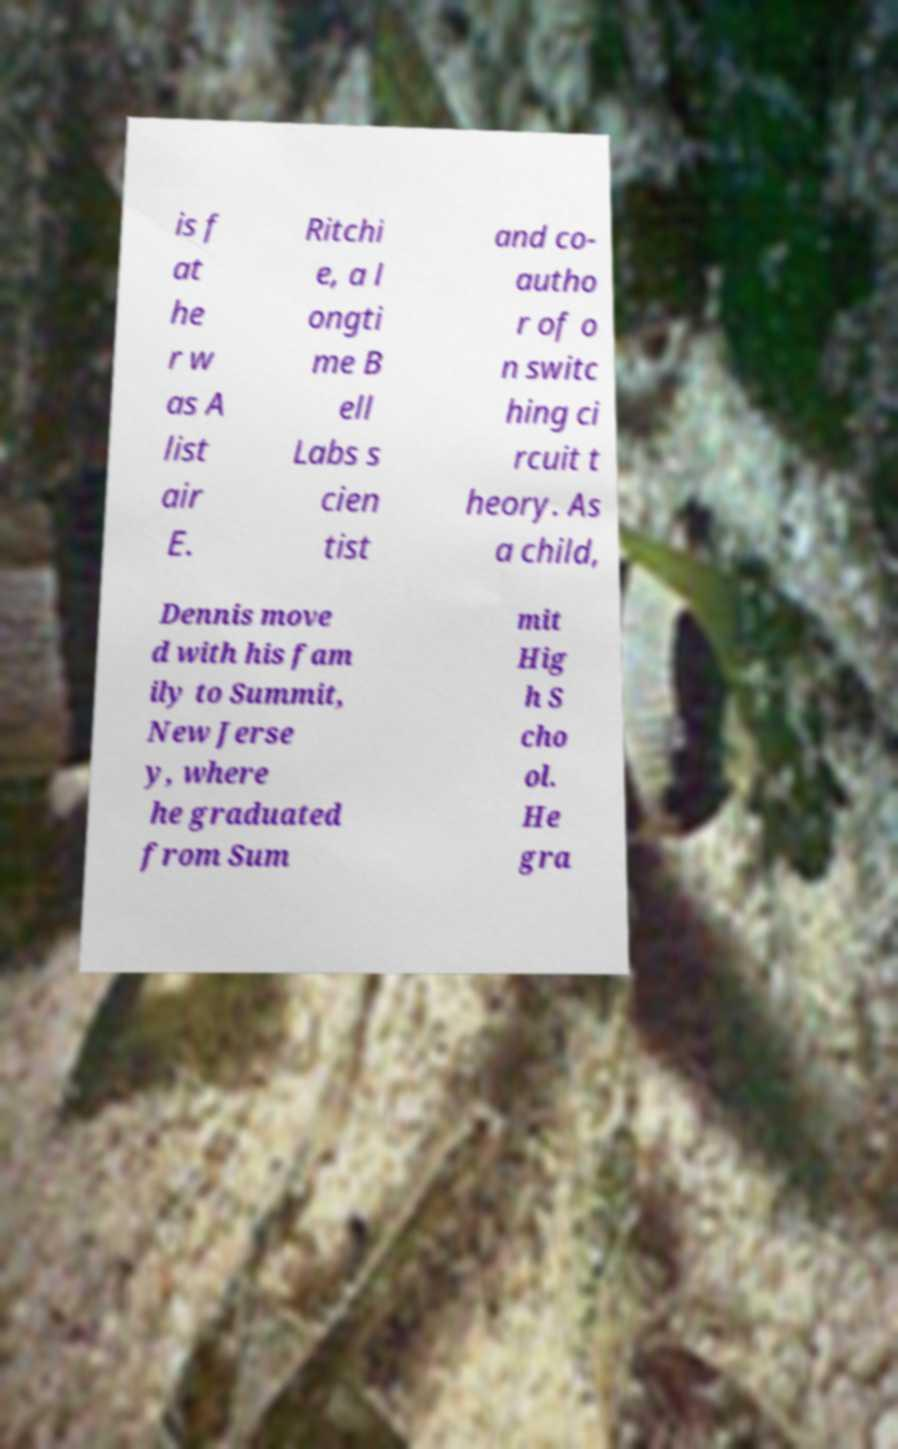Can you read and provide the text displayed in the image?This photo seems to have some interesting text. Can you extract and type it out for me? is f at he r w as A list air E. Ritchi e, a l ongti me B ell Labs s cien tist and co- autho r of o n switc hing ci rcuit t heory. As a child, Dennis move d with his fam ily to Summit, New Jerse y, where he graduated from Sum mit Hig h S cho ol. He gra 